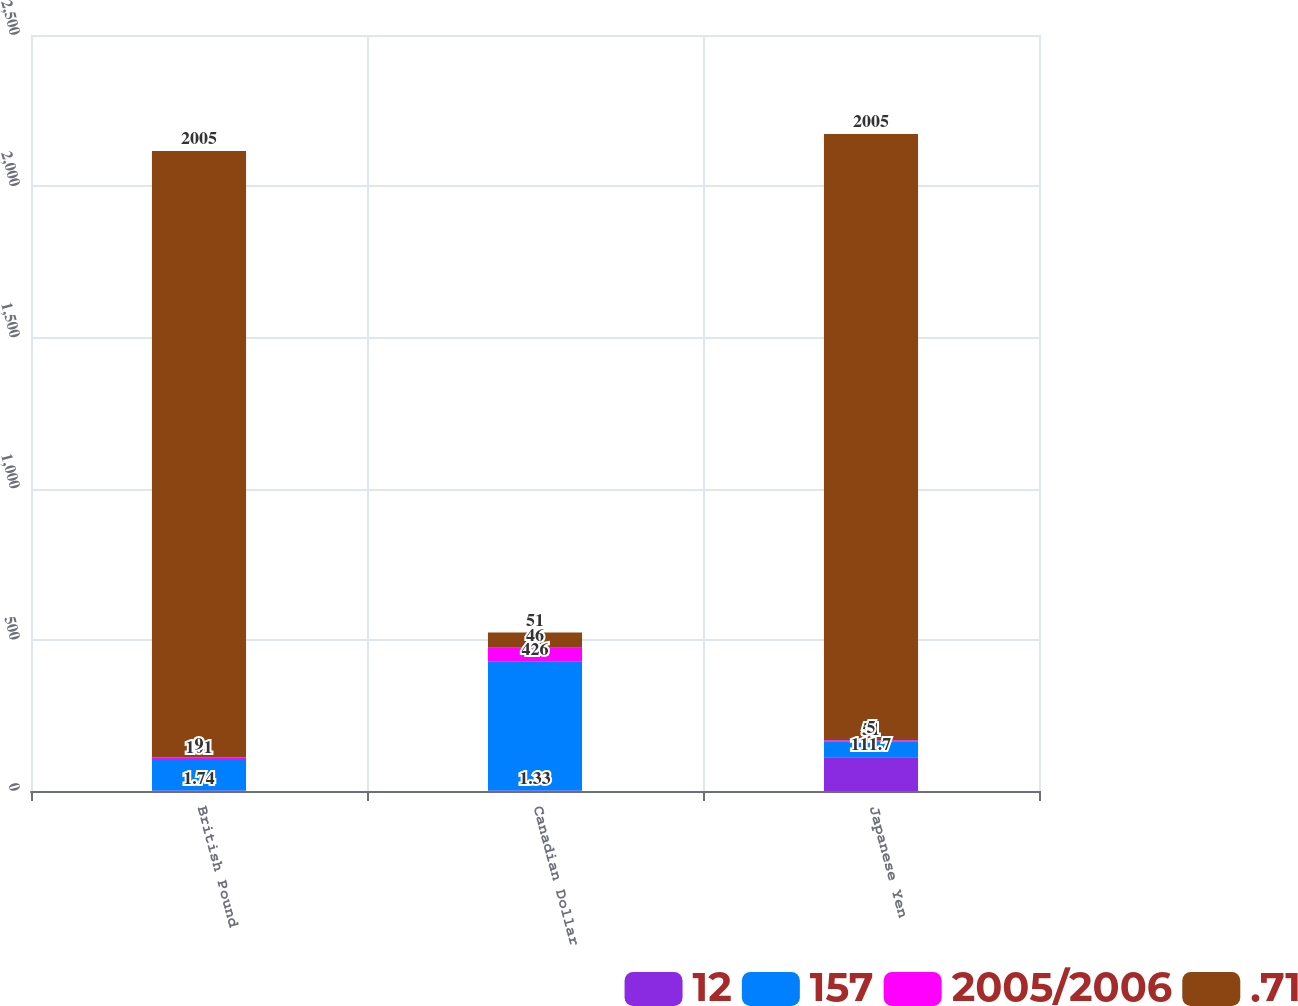<chart> <loc_0><loc_0><loc_500><loc_500><stacked_bar_chart><ecel><fcel>British Pound<fcel>Canadian Dollar<fcel>Japanese Yen<nl><fcel>12<fcel>1.74<fcel>1.33<fcel>111.7<nl><fcel>157<fcel>101<fcel>426<fcel>51<nl><fcel>2005/2006<fcel>9<fcel>46<fcel>5<nl><fcel>.71<fcel>2005<fcel>51<fcel>2005<nl></chart> 